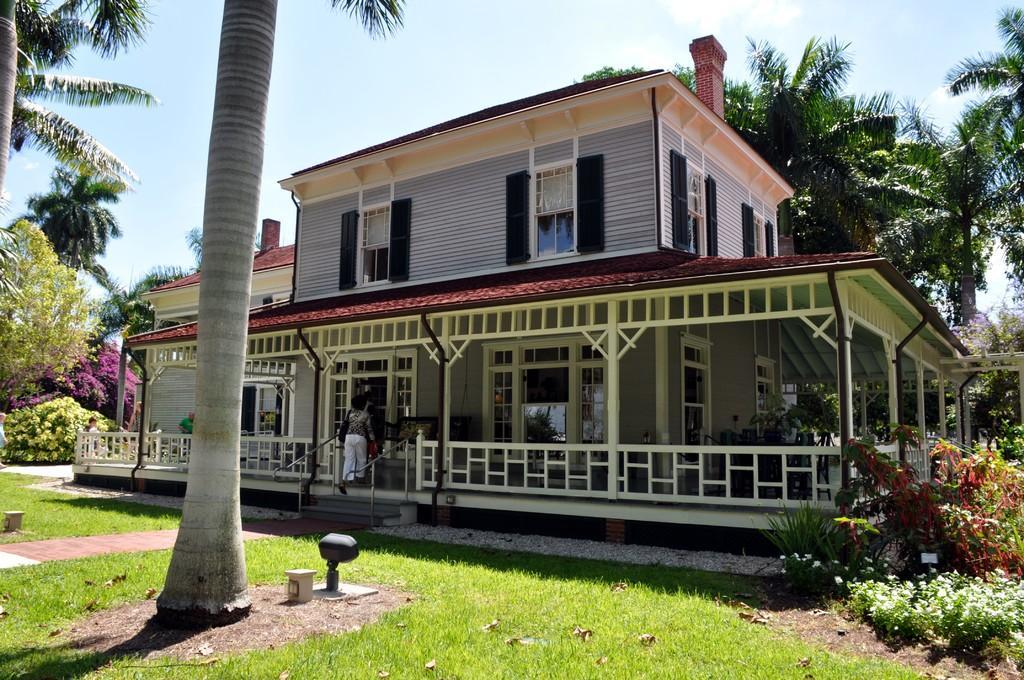In one or two sentences, can you explain what this image depicts? In this picture I can see a building and few trees and plants and I can see few of them walking and I can see a blue cloudy sky. 